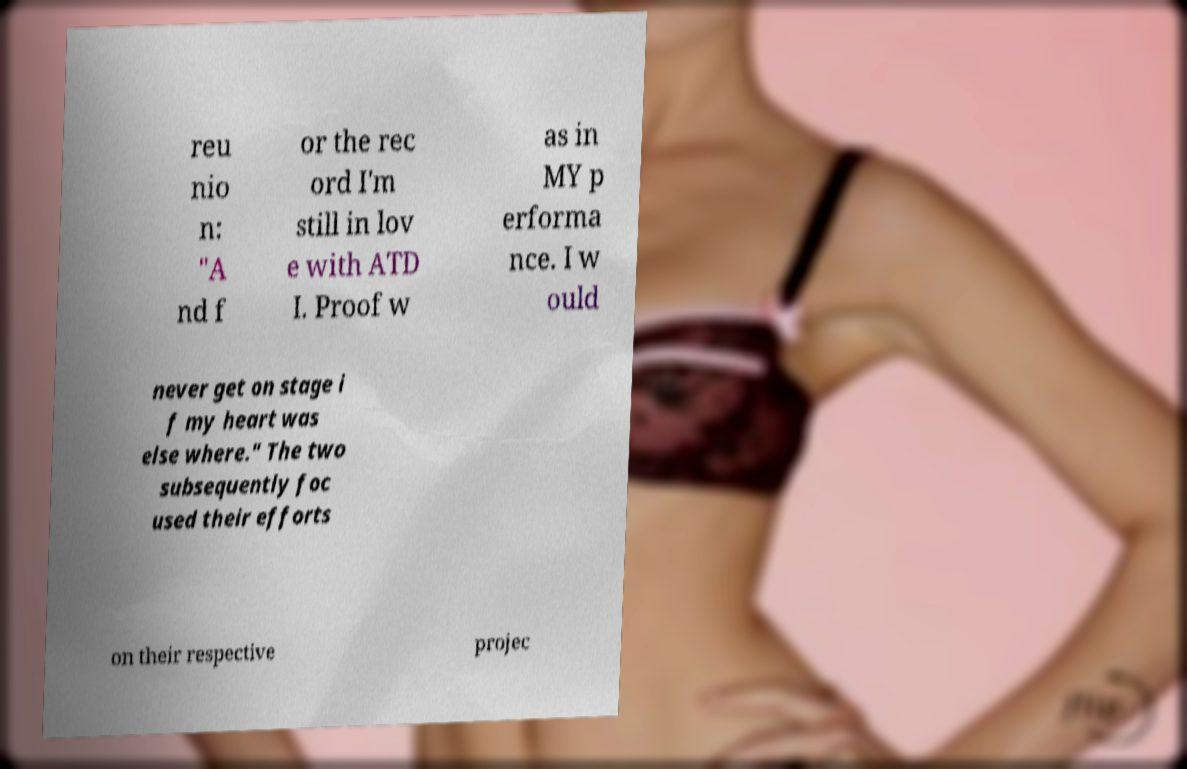Could you extract and type out the text from this image? reu nio n: "A nd f or the rec ord I'm still in lov e with ATD I. Proof w as in MY p erforma nce. I w ould never get on stage i f my heart was else where." The two subsequently foc used their efforts on their respective projec 